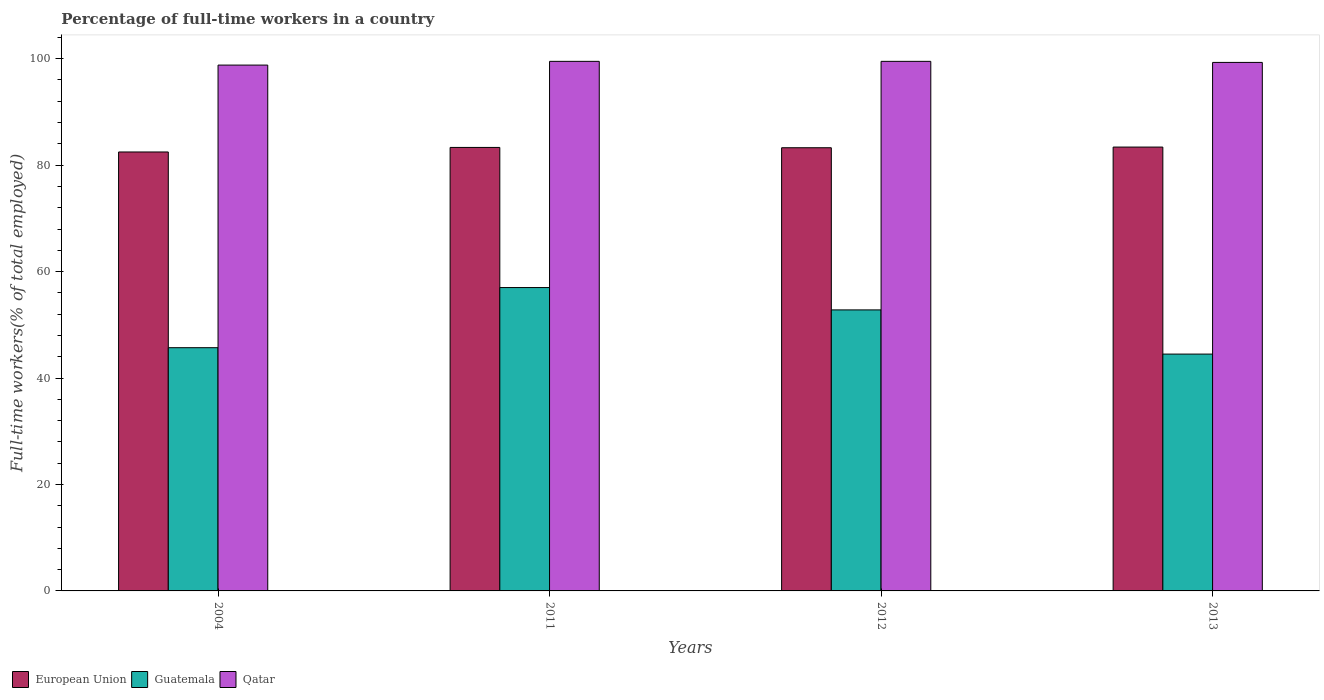How many different coloured bars are there?
Make the answer very short. 3. Are the number of bars on each tick of the X-axis equal?
Ensure brevity in your answer.  Yes. How many bars are there on the 2nd tick from the right?
Give a very brief answer. 3. What is the label of the 2nd group of bars from the left?
Your answer should be very brief. 2011. What is the percentage of full-time workers in Qatar in 2004?
Ensure brevity in your answer.  98.8. Across all years, what is the maximum percentage of full-time workers in Qatar?
Your answer should be compact. 99.5. Across all years, what is the minimum percentage of full-time workers in European Union?
Provide a succinct answer. 82.47. In which year was the percentage of full-time workers in Qatar minimum?
Your answer should be compact. 2004. What is the total percentage of full-time workers in European Union in the graph?
Provide a short and direct response. 332.46. What is the difference between the percentage of full-time workers in Qatar in 2004 and that in 2011?
Give a very brief answer. -0.7. What is the difference between the percentage of full-time workers in Guatemala in 2011 and the percentage of full-time workers in European Union in 2013?
Keep it short and to the point. -26.39. What is the average percentage of full-time workers in Qatar per year?
Offer a terse response. 99.28. In the year 2004, what is the difference between the percentage of full-time workers in Qatar and percentage of full-time workers in Guatemala?
Your answer should be very brief. 53.1. What is the ratio of the percentage of full-time workers in Qatar in 2011 to that in 2013?
Provide a short and direct response. 1. Is the percentage of full-time workers in European Union in 2011 less than that in 2012?
Ensure brevity in your answer.  No. Is the difference between the percentage of full-time workers in Qatar in 2004 and 2012 greater than the difference between the percentage of full-time workers in Guatemala in 2004 and 2012?
Offer a very short reply. Yes. What is the difference between the highest and the second highest percentage of full-time workers in Guatemala?
Your response must be concise. 4.2. What is the difference between the highest and the lowest percentage of full-time workers in European Union?
Provide a succinct answer. 0.92. In how many years, is the percentage of full-time workers in Qatar greater than the average percentage of full-time workers in Qatar taken over all years?
Give a very brief answer. 3. What does the 3rd bar from the left in 2013 represents?
Your response must be concise. Qatar. What does the 3rd bar from the right in 2012 represents?
Your answer should be compact. European Union. Is it the case that in every year, the sum of the percentage of full-time workers in Qatar and percentage of full-time workers in Guatemala is greater than the percentage of full-time workers in European Union?
Give a very brief answer. Yes. What is the difference between two consecutive major ticks on the Y-axis?
Your answer should be compact. 20. Does the graph contain grids?
Offer a very short reply. No. Where does the legend appear in the graph?
Ensure brevity in your answer.  Bottom left. How are the legend labels stacked?
Offer a very short reply. Horizontal. What is the title of the graph?
Offer a very short reply. Percentage of full-time workers in a country. What is the label or title of the Y-axis?
Your answer should be compact. Full-time workers(% of total employed). What is the Full-time workers(% of total employed) of European Union in 2004?
Your response must be concise. 82.47. What is the Full-time workers(% of total employed) of Guatemala in 2004?
Make the answer very short. 45.7. What is the Full-time workers(% of total employed) of Qatar in 2004?
Ensure brevity in your answer.  98.8. What is the Full-time workers(% of total employed) in European Union in 2011?
Provide a short and direct response. 83.33. What is the Full-time workers(% of total employed) in Qatar in 2011?
Your response must be concise. 99.5. What is the Full-time workers(% of total employed) of European Union in 2012?
Provide a short and direct response. 83.27. What is the Full-time workers(% of total employed) in Guatemala in 2012?
Make the answer very short. 52.8. What is the Full-time workers(% of total employed) in Qatar in 2012?
Offer a very short reply. 99.5. What is the Full-time workers(% of total employed) in European Union in 2013?
Your answer should be compact. 83.39. What is the Full-time workers(% of total employed) in Guatemala in 2013?
Provide a short and direct response. 44.5. What is the Full-time workers(% of total employed) of Qatar in 2013?
Your answer should be very brief. 99.3. Across all years, what is the maximum Full-time workers(% of total employed) in European Union?
Offer a very short reply. 83.39. Across all years, what is the maximum Full-time workers(% of total employed) of Qatar?
Your answer should be very brief. 99.5. Across all years, what is the minimum Full-time workers(% of total employed) in European Union?
Offer a terse response. 82.47. Across all years, what is the minimum Full-time workers(% of total employed) in Guatemala?
Your answer should be compact. 44.5. Across all years, what is the minimum Full-time workers(% of total employed) of Qatar?
Your answer should be very brief. 98.8. What is the total Full-time workers(% of total employed) of European Union in the graph?
Offer a terse response. 332.46. What is the total Full-time workers(% of total employed) in Qatar in the graph?
Give a very brief answer. 397.1. What is the difference between the Full-time workers(% of total employed) in European Union in 2004 and that in 2011?
Your response must be concise. -0.85. What is the difference between the Full-time workers(% of total employed) of Guatemala in 2004 and that in 2011?
Your response must be concise. -11.3. What is the difference between the Full-time workers(% of total employed) in Qatar in 2004 and that in 2011?
Your answer should be very brief. -0.7. What is the difference between the Full-time workers(% of total employed) of European Union in 2004 and that in 2012?
Keep it short and to the point. -0.79. What is the difference between the Full-time workers(% of total employed) of European Union in 2004 and that in 2013?
Your response must be concise. -0.92. What is the difference between the Full-time workers(% of total employed) of European Union in 2011 and that in 2012?
Ensure brevity in your answer.  0.06. What is the difference between the Full-time workers(% of total employed) of Guatemala in 2011 and that in 2012?
Provide a succinct answer. 4.2. What is the difference between the Full-time workers(% of total employed) of European Union in 2011 and that in 2013?
Offer a terse response. -0.07. What is the difference between the Full-time workers(% of total employed) of Guatemala in 2011 and that in 2013?
Ensure brevity in your answer.  12.5. What is the difference between the Full-time workers(% of total employed) in Qatar in 2011 and that in 2013?
Make the answer very short. 0.2. What is the difference between the Full-time workers(% of total employed) in European Union in 2012 and that in 2013?
Your answer should be very brief. -0.13. What is the difference between the Full-time workers(% of total employed) of European Union in 2004 and the Full-time workers(% of total employed) of Guatemala in 2011?
Your answer should be very brief. 25.47. What is the difference between the Full-time workers(% of total employed) of European Union in 2004 and the Full-time workers(% of total employed) of Qatar in 2011?
Provide a succinct answer. -17.03. What is the difference between the Full-time workers(% of total employed) in Guatemala in 2004 and the Full-time workers(% of total employed) in Qatar in 2011?
Provide a succinct answer. -53.8. What is the difference between the Full-time workers(% of total employed) of European Union in 2004 and the Full-time workers(% of total employed) of Guatemala in 2012?
Your answer should be compact. 29.67. What is the difference between the Full-time workers(% of total employed) of European Union in 2004 and the Full-time workers(% of total employed) of Qatar in 2012?
Your answer should be compact. -17.03. What is the difference between the Full-time workers(% of total employed) of Guatemala in 2004 and the Full-time workers(% of total employed) of Qatar in 2012?
Provide a short and direct response. -53.8. What is the difference between the Full-time workers(% of total employed) in European Union in 2004 and the Full-time workers(% of total employed) in Guatemala in 2013?
Provide a succinct answer. 37.97. What is the difference between the Full-time workers(% of total employed) in European Union in 2004 and the Full-time workers(% of total employed) in Qatar in 2013?
Your response must be concise. -16.83. What is the difference between the Full-time workers(% of total employed) in Guatemala in 2004 and the Full-time workers(% of total employed) in Qatar in 2013?
Keep it short and to the point. -53.6. What is the difference between the Full-time workers(% of total employed) in European Union in 2011 and the Full-time workers(% of total employed) in Guatemala in 2012?
Your response must be concise. 30.53. What is the difference between the Full-time workers(% of total employed) of European Union in 2011 and the Full-time workers(% of total employed) of Qatar in 2012?
Ensure brevity in your answer.  -16.17. What is the difference between the Full-time workers(% of total employed) in Guatemala in 2011 and the Full-time workers(% of total employed) in Qatar in 2012?
Ensure brevity in your answer.  -42.5. What is the difference between the Full-time workers(% of total employed) of European Union in 2011 and the Full-time workers(% of total employed) of Guatemala in 2013?
Keep it short and to the point. 38.83. What is the difference between the Full-time workers(% of total employed) of European Union in 2011 and the Full-time workers(% of total employed) of Qatar in 2013?
Make the answer very short. -15.97. What is the difference between the Full-time workers(% of total employed) in Guatemala in 2011 and the Full-time workers(% of total employed) in Qatar in 2013?
Your response must be concise. -42.3. What is the difference between the Full-time workers(% of total employed) of European Union in 2012 and the Full-time workers(% of total employed) of Guatemala in 2013?
Your answer should be compact. 38.77. What is the difference between the Full-time workers(% of total employed) of European Union in 2012 and the Full-time workers(% of total employed) of Qatar in 2013?
Give a very brief answer. -16.03. What is the difference between the Full-time workers(% of total employed) of Guatemala in 2012 and the Full-time workers(% of total employed) of Qatar in 2013?
Provide a short and direct response. -46.5. What is the average Full-time workers(% of total employed) in European Union per year?
Make the answer very short. 83.12. What is the average Full-time workers(% of total employed) of Qatar per year?
Provide a short and direct response. 99.28. In the year 2004, what is the difference between the Full-time workers(% of total employed) in European Union and Full-time workers(% of total employed) in Guatemala?
Keep it short and to the point. 36.77. In the year 2004, what is the difference between the Full-time workers(% of total employed) of European Union and Full-time workers(% of total employed) of Qatar?
Provide a succinct answer. -16.33. In the year 2004, what is the difference between the Full-time workers(% of total employed) in Guatemala and Full-time workers(% of total employed) in Qatar?
Your response must be concise. -53.1. In the year 2011, what is the difference between the Full-time workers(% of total employed) in European Union and Full-time workers(% of total employed) in Guatemala?
Give a very brief answer. 26.33. In the year 2011, what is the difference between the Full-time workers(% of total employed) in European Union and Full-time workers(% of total employed) in Qatar?
Provide a succinct answer. -16.17. In the year 2011, what is the difference between the Full-time workers(% of total employed) in Guatemala and Full-time workers(% of total employed) in Qatar?
Offer a terse response. -42.5. In the year 2012, what is the difference between the Full-time workers(% of total employed) of European Union and Full-time workers(% of total employed) of Guatemala?
Your response must be concise. 30.47. In the year 2012, what is the difference between the Full-time workers(% of total employed) of European Union and Full-time workers(% of total employed) of Qatar?
Give a very brief answer. -16.23. In the year 2012, what is the difference between the Full-time workers(% of total employed) of Guatemala and Full-time workers(% of total employed) of Qatar?
Provide a succinct answer. -46.7. In the year 2013, what is the difference between the Full-time workers(% of total employed) of European Union and Full-time workers(% of total employed) of Guatemala?
Ensure brevity in your answer.  38.89. In the year 2013, what is the difference between the Full-time workers(% of total employed) in European Union and Full-time workers(% of total employed) in Qatar?
Keep it short and to the point. -15.91. In the year 2013, what is the difference between the Full-time workers(% of total employed) in Guatemala and Full-time workers(% of total employed) in Qatar?
Offer a terse response. -54.8. What is the ratio of the Full-time workers(% of total employed) of Guatemala in 2004 to that in 2011?
Offer a terse response. 0.8. What is the ratio of the Full-time workers(% of total employed) in Qatar in 2004 to that in 2011?
Ensure brevity in your answer.  0.99. What is the ratio of the Full-time workers(% of total employed) in Guatemala in 2004 to that in 2012?
Your answer should be very brief. 0.87. What is the ratio of the Full-time workers(% of total employed) of Qatar in 2004 to that in 2012?
Give a very brief answer. 0.99. What is the ratio of the Full-time workers(% of total employed) in European Union in 2004 to that in 2013?
Keep it short and to the point. 0.99. What is the ratio of the Full-time workers(% of total employed) of Qatar in 2004 to that in 2013?
Your answer should be compact. 0.99. What is the ratio of the Full-time workers(% of total employed) of European Union in 2011 to that in 2012?
Ensure brevity in your answer.  1. What is the ratio of the Full-time workers(% of total employed) in Guatemala in 2011 to that in 2012?
Keep it short and to the point. 1.08. What is the ratio of the Full-time workers(% of total employed) of European Union in 2011 to that in 2013?
Make the answer very short. 1. What is the ratio of the Full-time workers(% of total employed) of Guatemala in 2011 to that in 2013?
Ensure brevity in your answer.  1.28. What is the ratio of the Full-time workers(% of total employed) in European Union in 2012 to that in 2013?
Provide a succinct answer. 1. What is the ratio of the Full-time workers(% of total employed) of Guatemala in 2012 to that in 2013?
Make the answer very short. 1.19. What is the difference between the highest and the second highest Full-time workers(% of total employed) in European Union?
Offer a terse response. 0.07. What is the difference between the highest and the second highest Full-time workers(% of total employed) of Qatar?
Ensure brevity in your answer.  0. What is the difference between the highest and the lowest Full-time workers(% of total employed) in European Union?
Keep it short and to the point. 0.92. What is the difference between the highest and the lowest Full-time workers(% of total employed) of Guatemala?
Offer a terse response. 12.5. 